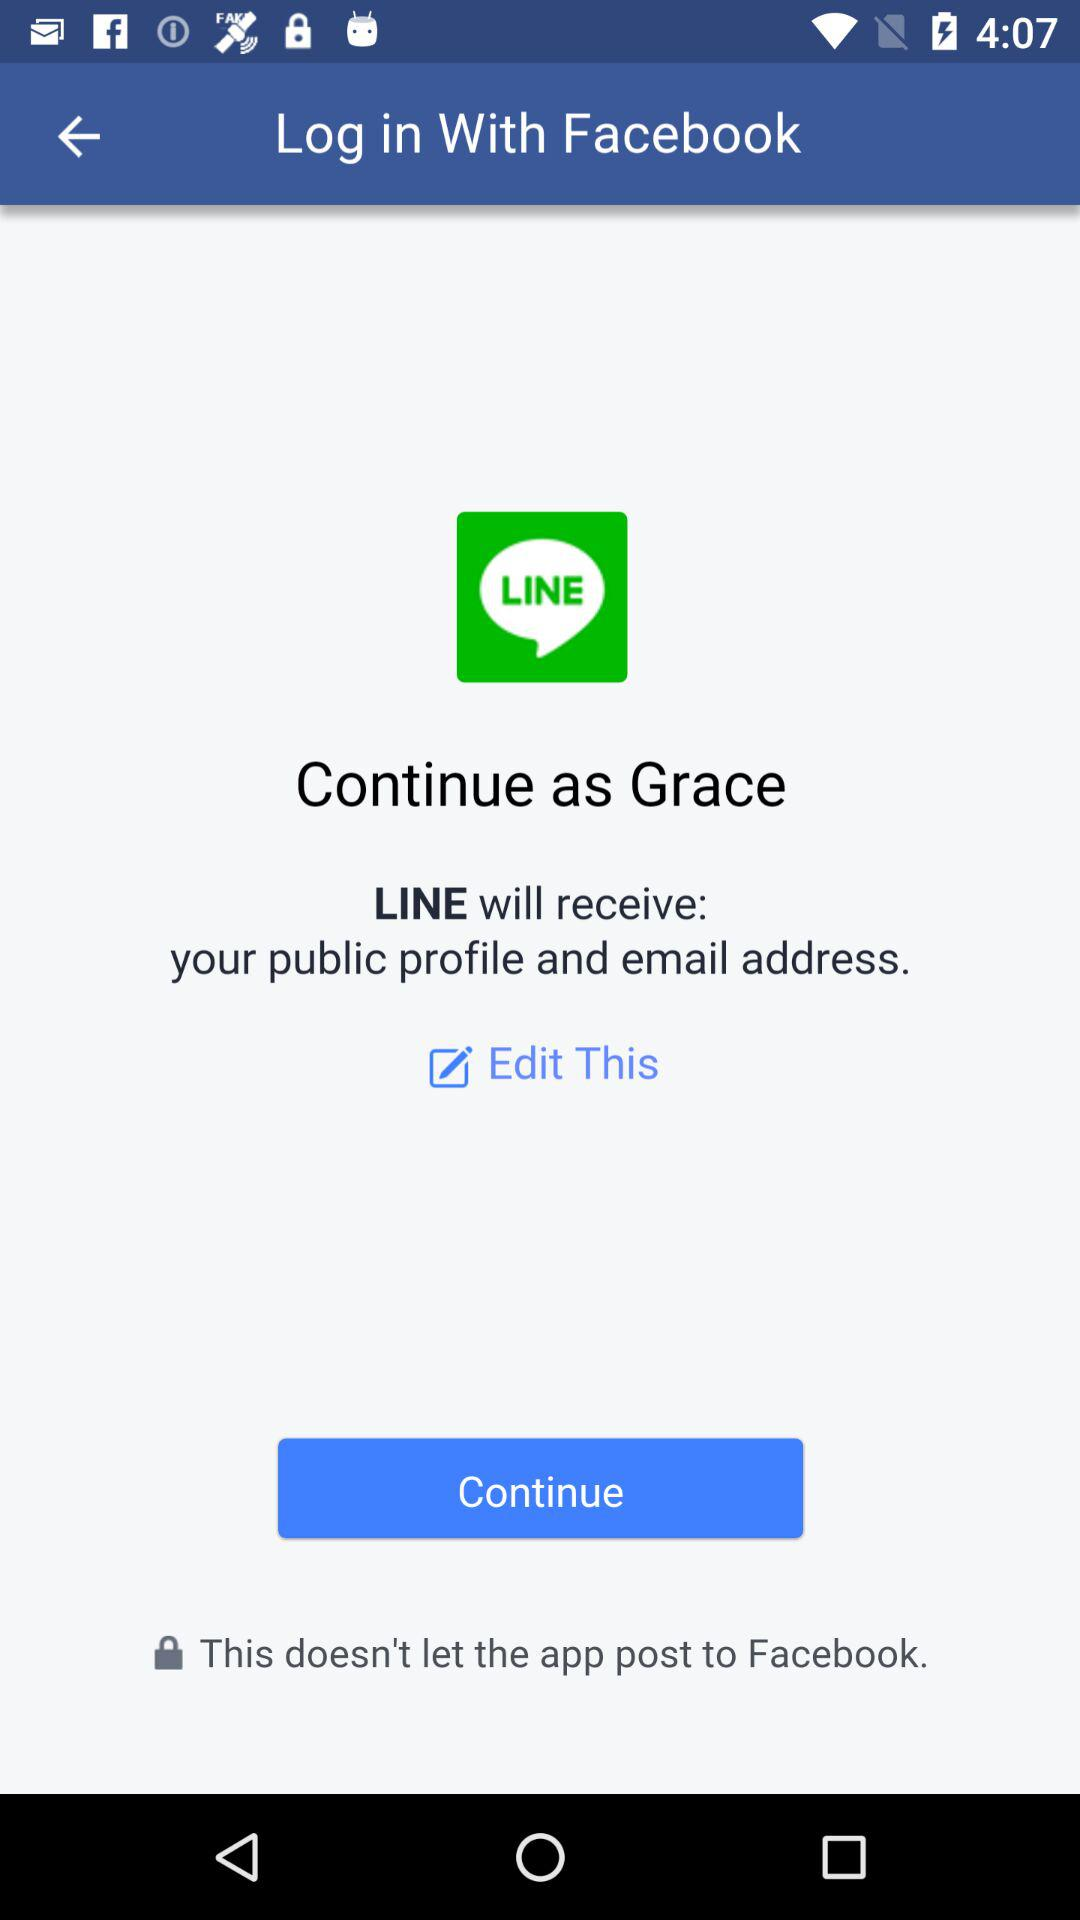What's the user name? The user name is Grace. 